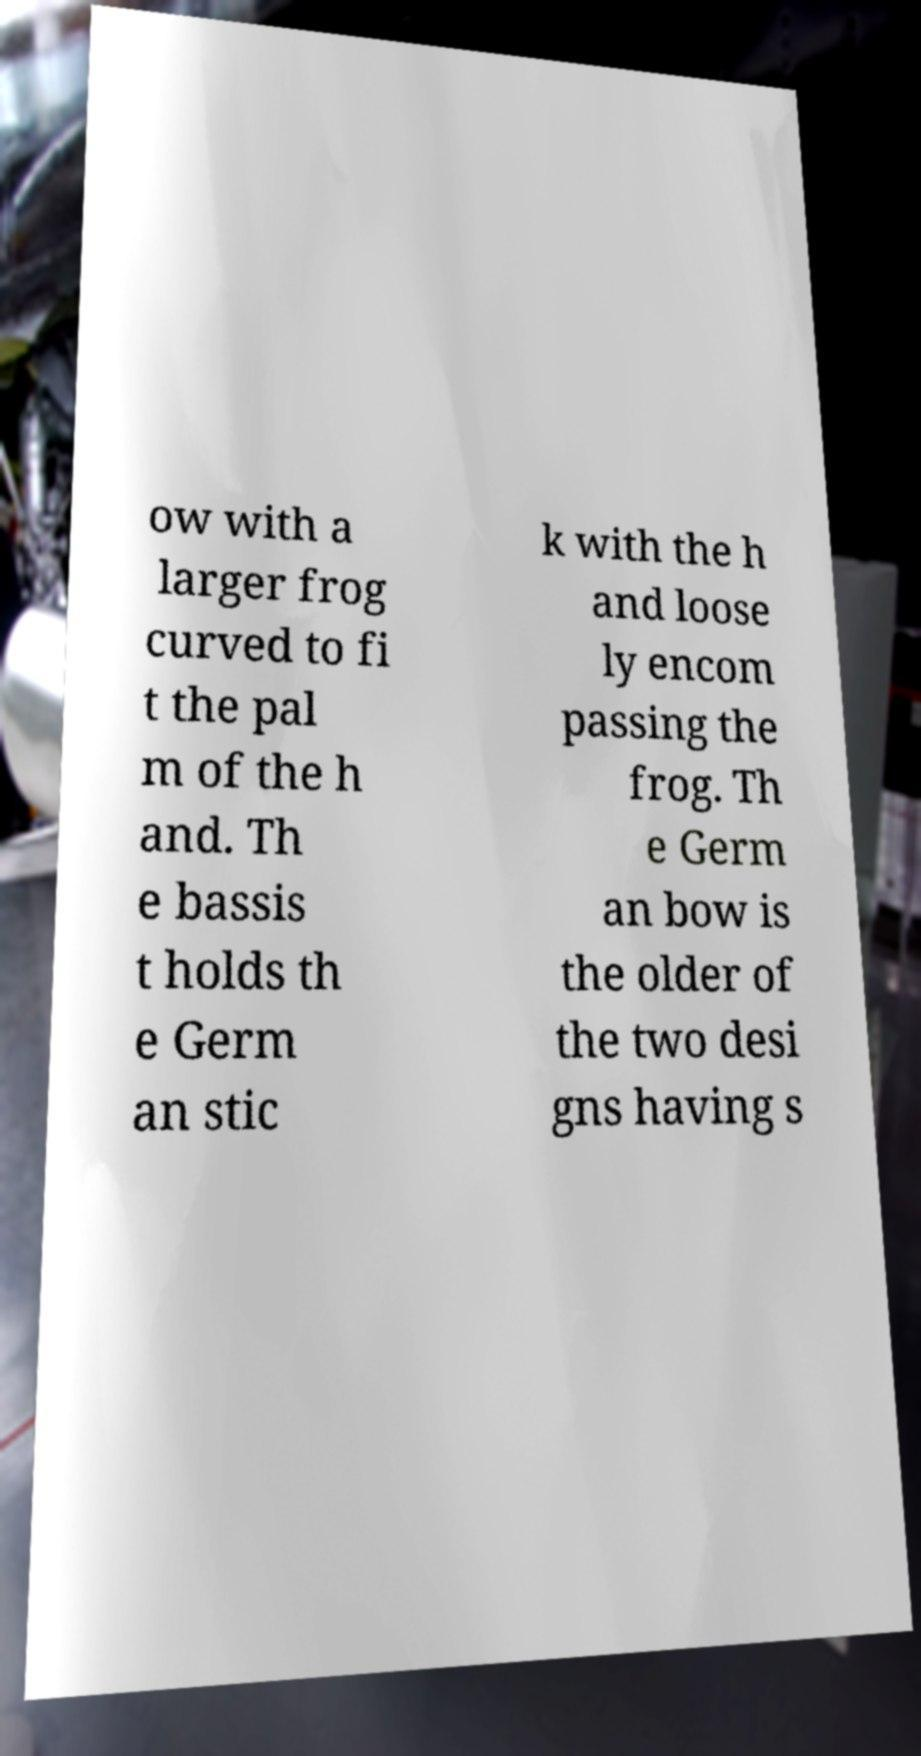Please read and relay the text visible in this image. What does it say? ow with a larger frog curved to fi t the pal m of the h and. Th e bassis t holds th e Germ an stic k with the h and loose ly encom passing the frog. Th e Germ an bow is the older of the two desi gns having s 